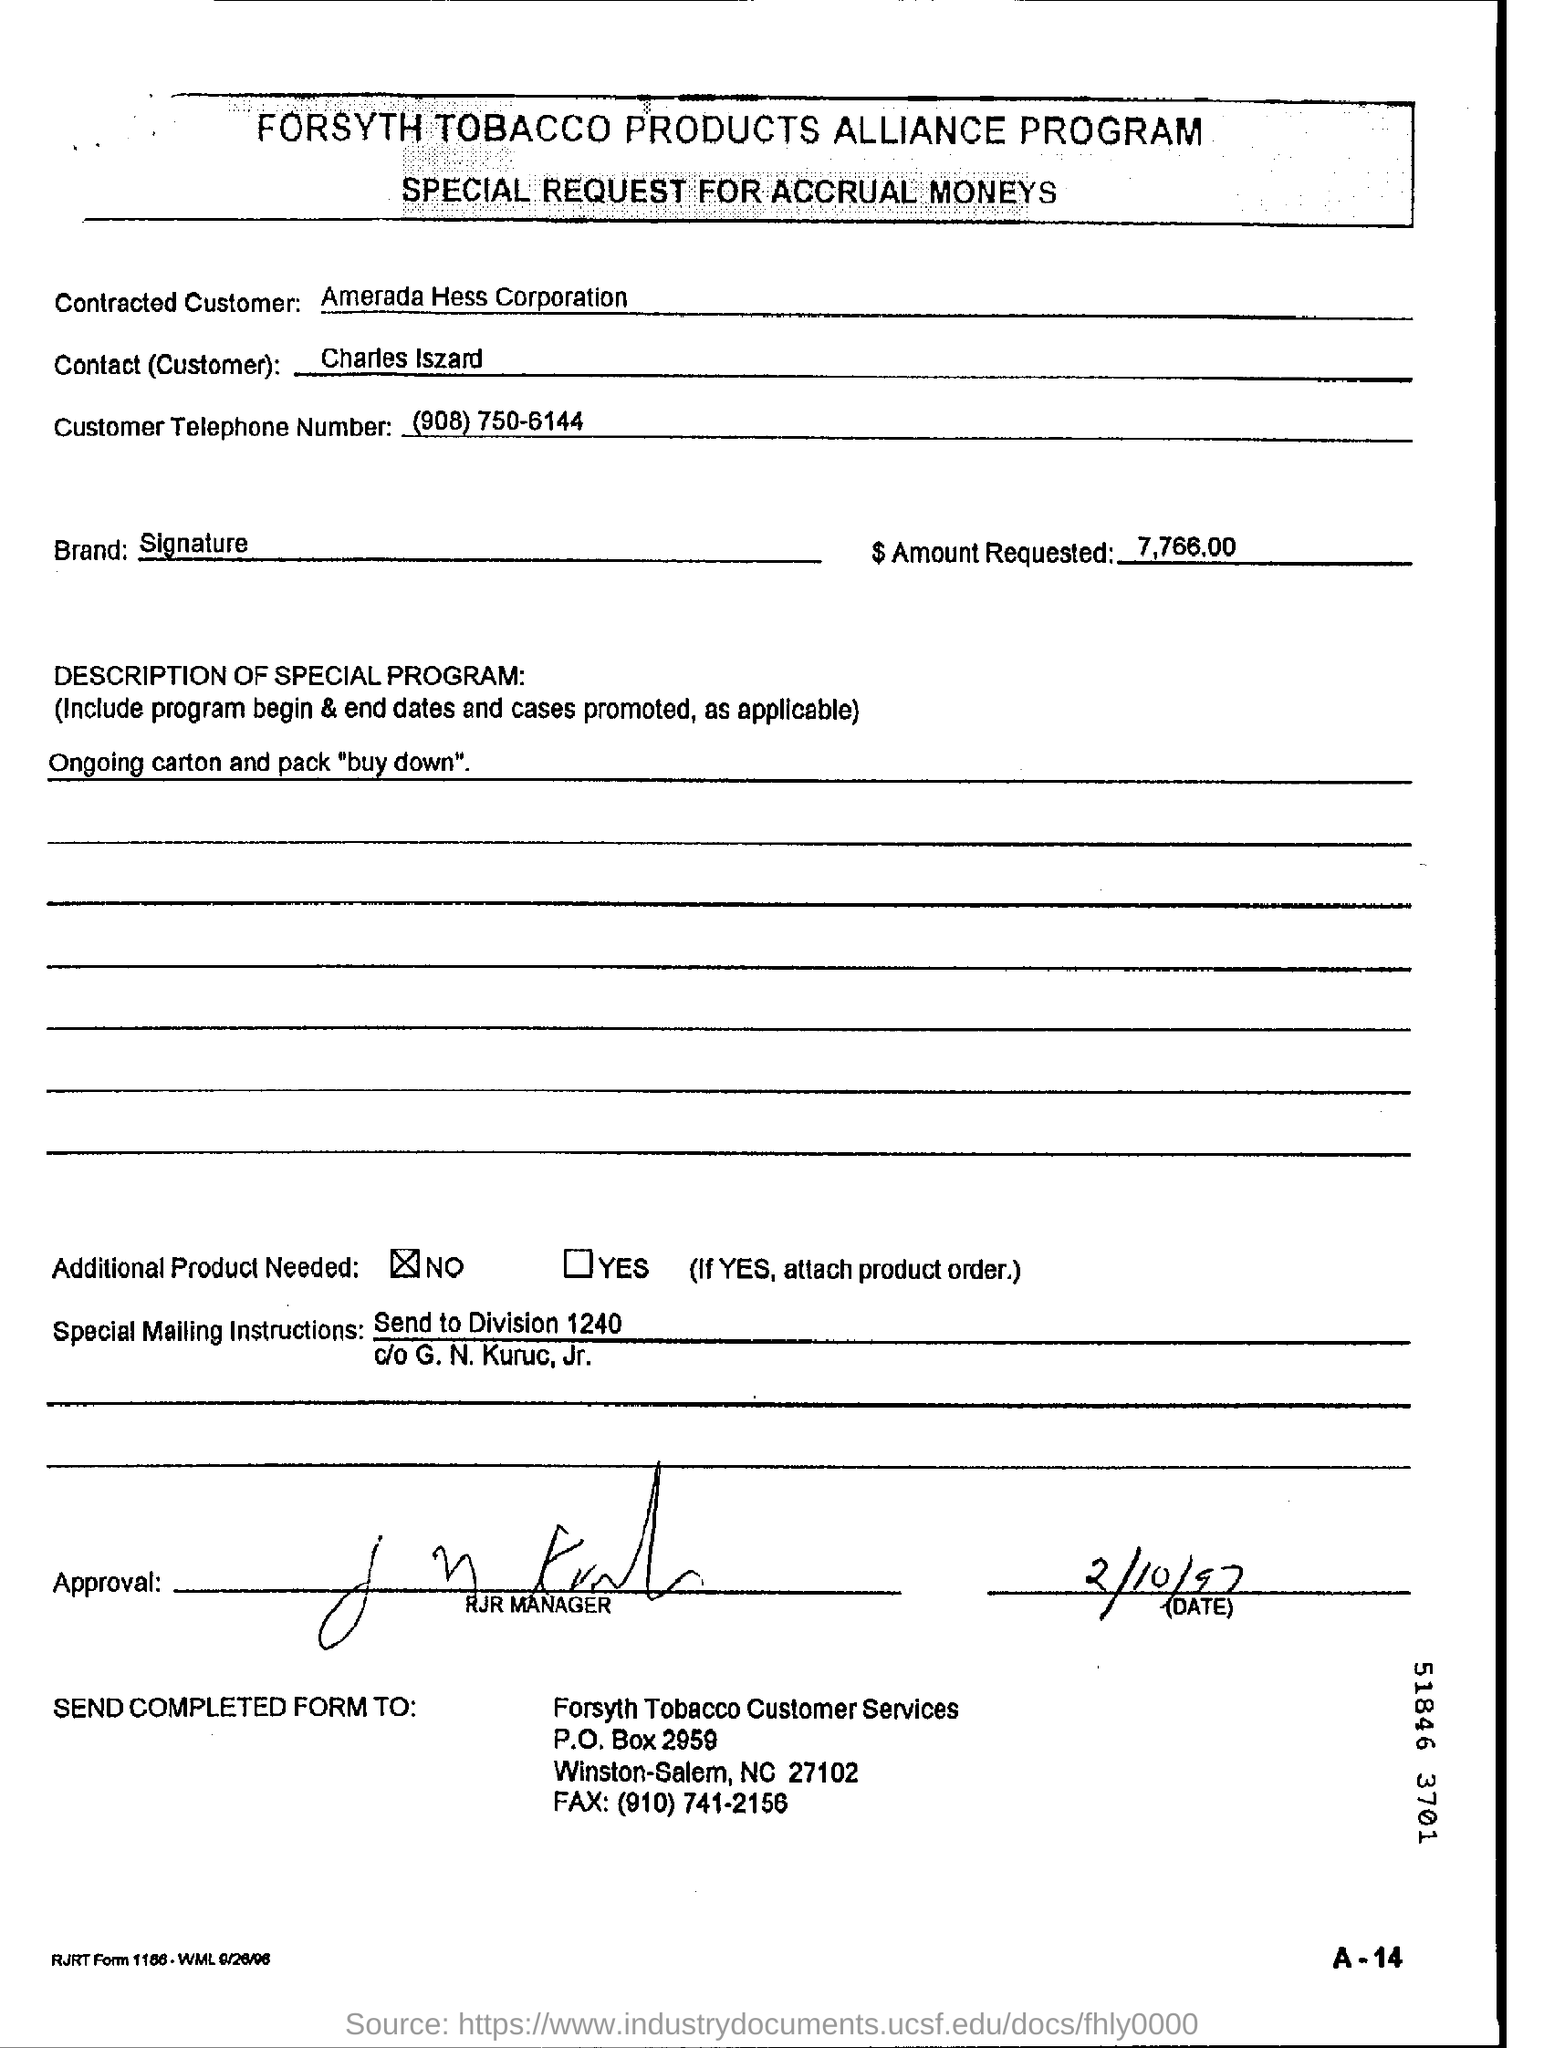Outline some significant characteristics in this image. The Amerada Hess Corporation is the contracted customer. The requested amount is $7,766.00. The Contact(Customer) is Charles Iszard. The customer's telephone number is (908)750-6144. 